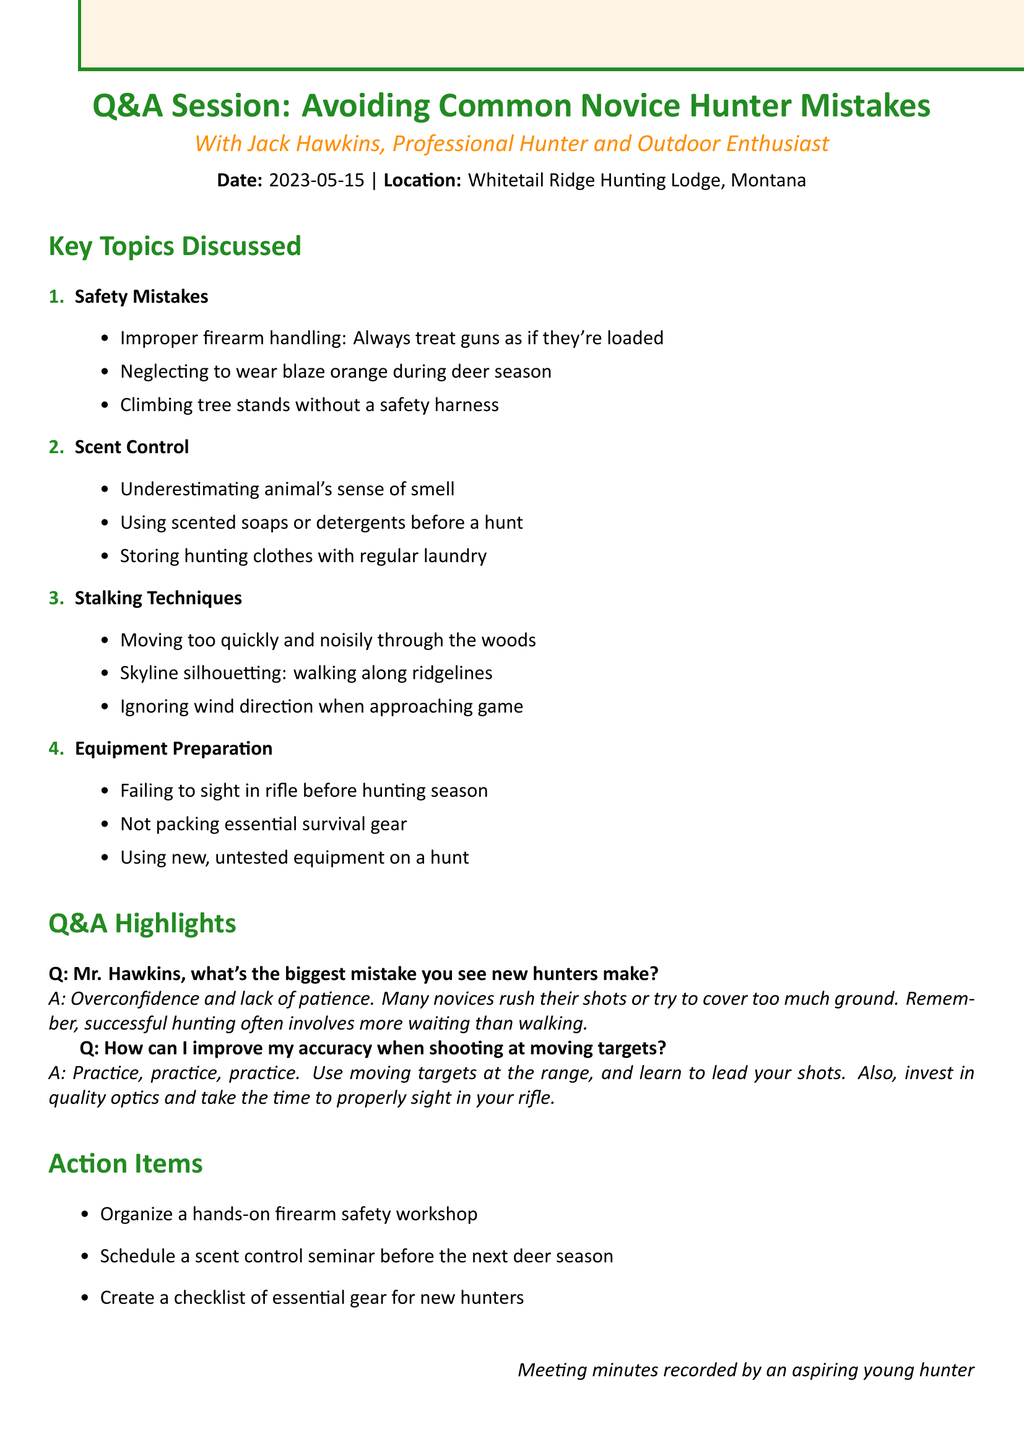what is the title of the meeting? The title is stated at the top of the document, indicating the focus of the session.
Answer: Q&A Session: Avoiding Common Novice Hunter Mistakes who was the presenter? The presenter is listed in the introduction of the document, providing insight into their expertise.
Answer: Jack Hawkins what date did the meeting take place? The date is clearly mentioned in the document along with the location.
Answer: 2023-05-15 how many key topics were discussed? The document outlines the key topics in a numbered list, making it easy to identify the total.
Answer: 4 what is one of the action items proposed? Action items are listed at the end of the document, indicating organized efforts post-meeting.
Answer: Organize a hands-on firearm safety workshop what is the biggest mistake new hunters make according to Mr. Hawkins? This is directly quoted from the Q&A highlights, summarizing a common issue faced by novices.
Answer: Overconfidence and lack of patience how can novice hunters improve their accuracy? The answer is found in the Q&A section, providing practical advice for aspiring hunters.
Answer: Practice, practice, practice what location hosted the meeting? The location where the meeting took place is mentioned with the date, giving context to the event.
Answer: Whitetail Ridge Hunting Lodge, Montana 